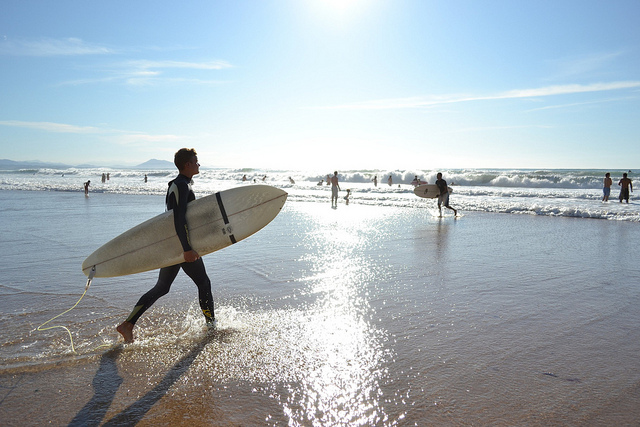How many legs is the bear standing on? Since the image shows a person with a surfboard at the beach, and no bear is visible, the question is based on a misunderstanding. Upon reviewing the image content, I can provide insights related to the actual scene. 